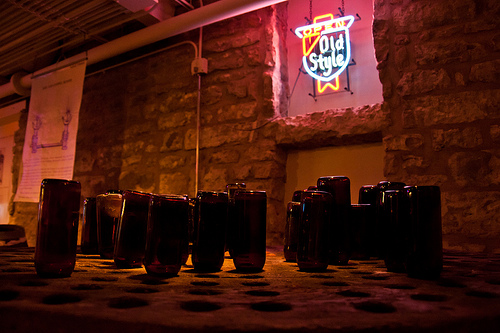<image>
Is the bottle in the hole? Yes. The bottle is contained within or inside the hole, showing a containment relationship. 